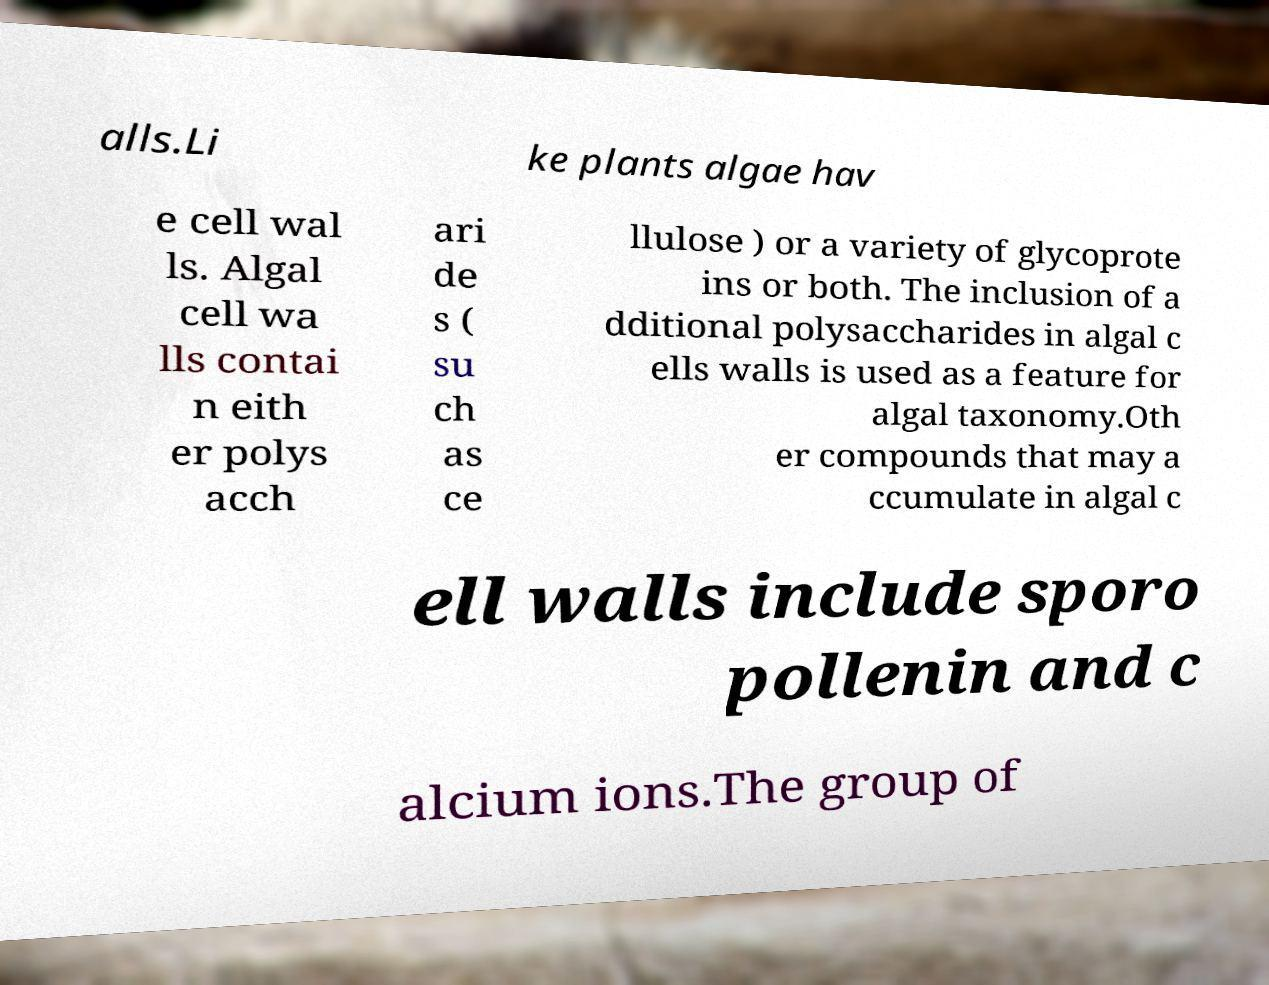Can you accurately transcribe the text from the provided image for me? alls.Li ke plants algae hav e cell wal ls. Algal cell wa lls contai n eith er polys acch ari de s ( su ch as ce llulose ) or a variety of glycoprote ins or both. The inclusion of a dditional polysaccharides in algal c ells walls is used as a feature for algal taxonomy.Oth er compounds that may a ccumulate in algal c ell walls include sporo pollenin and c alcium ions.The group of 